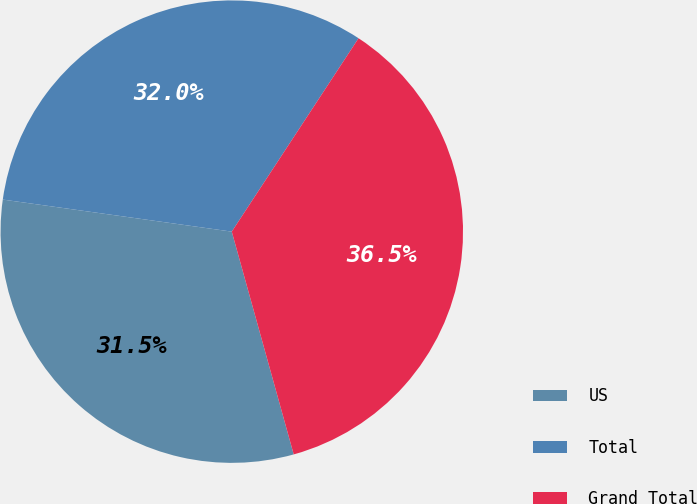Convert chart to OTSL. <chart><loc_0><loc_0><loc_500><loc_500><pie_chart><fcel>US<fcel>Total<fcel>Grand Total<nl><fcel>31.53%<fcel>32.02%<fcel>36.45%<nl></chart> 